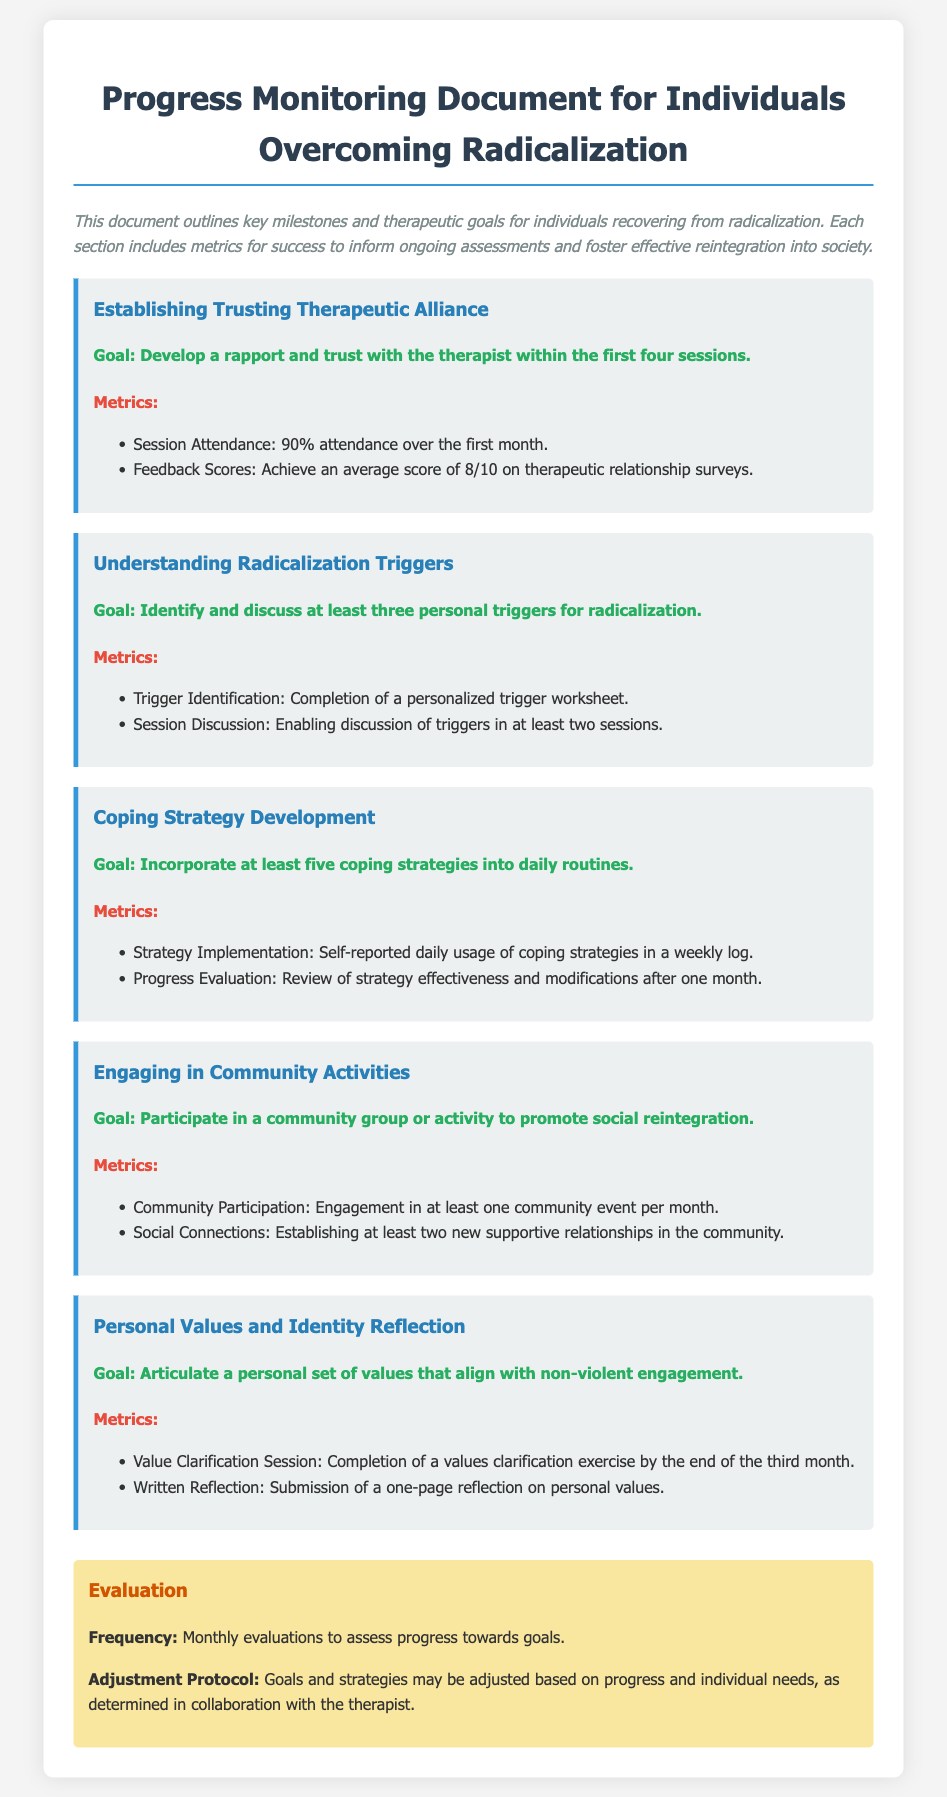What is the title of the document? The title appears prominently at the top of the document and indicates the subject matter.
Answer: Progress Monitoring Document for Individuals Overcoming Radicalization What percentage of attendance is expected in the first month? The attendance metric is specified under the first milestone about establishing a therapeutic alliance.
Answer: 90% How many personal triggers for radicalization should be identified? This information is found under the second milestone, indicating a goal to identify specific triggers.
Answer: three What is the goal for community activities participation? The goal stated under the fourth milestone indicates the nature of expected engagement in community activities.
Answer: Participate in a community group or activity What is the frequency of evaluations? This detail is mentioned in the evaluation section, reflecting the assessment process for progress.
Answer: Monthly How many coping strategies should be incorporated? This requirement is specified in the third milestone related to coping strategy development.
Answer: five What color is used for the background of the evaluation section? The color of this section is described in the styling comments within the document style section.
Answer: Yellow What is the average feedback score target on therapeutic relationship surveys? This numeric goal is outlined in the metrics for establishing a therapeutic alliance.
Answer: 8/10 